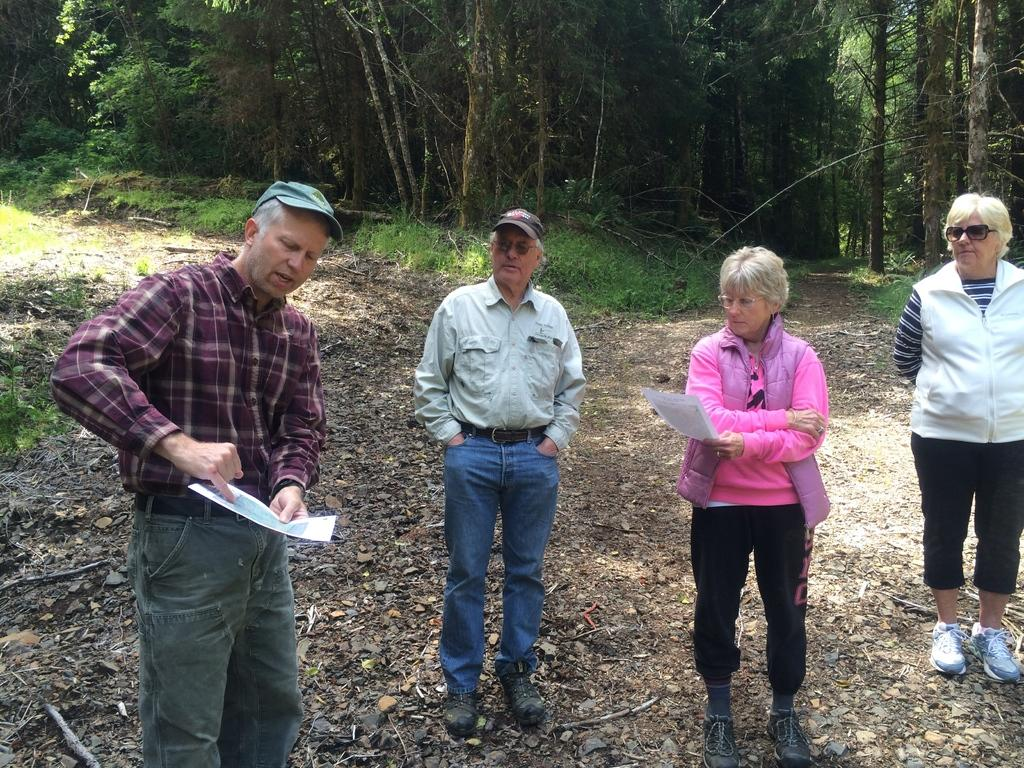What is happening in the image involving people? There are people standing in the image. What are two of the people holding in their hands? Two persons are holding paper in their hands. What type of natural environment can be seen in the image? There are trees visible in the image, and grass is present on the ground. What type of vegetable is being gripped by the stick in the image? There is no vegetable or stick present in the image. 